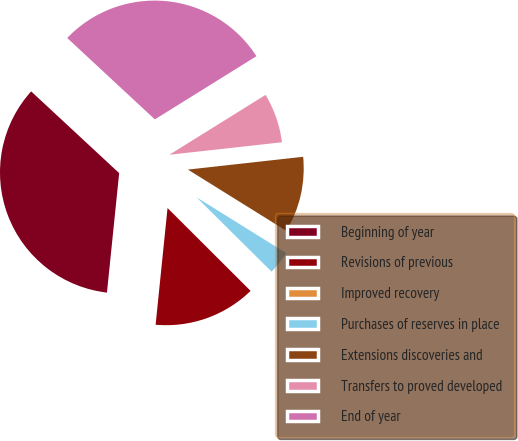<chart> <loc_0><loc_0><loc_500><loc_500><pie_chart><fcel>Beginning of year<fcel>Revisions of previous<fcel>Improved recovery<fcel>Purchases of reserves in place<fcel>Extensions discoveries and<fcel>Transfers to proved developed<fcel>End of year<nl><fcel>35.29%<fcel>14.14%<fcel>0.05%<fcel>3.57%<fcel>10.62%<fcel>7.1%<fcel>29.23%<nl></chart> 